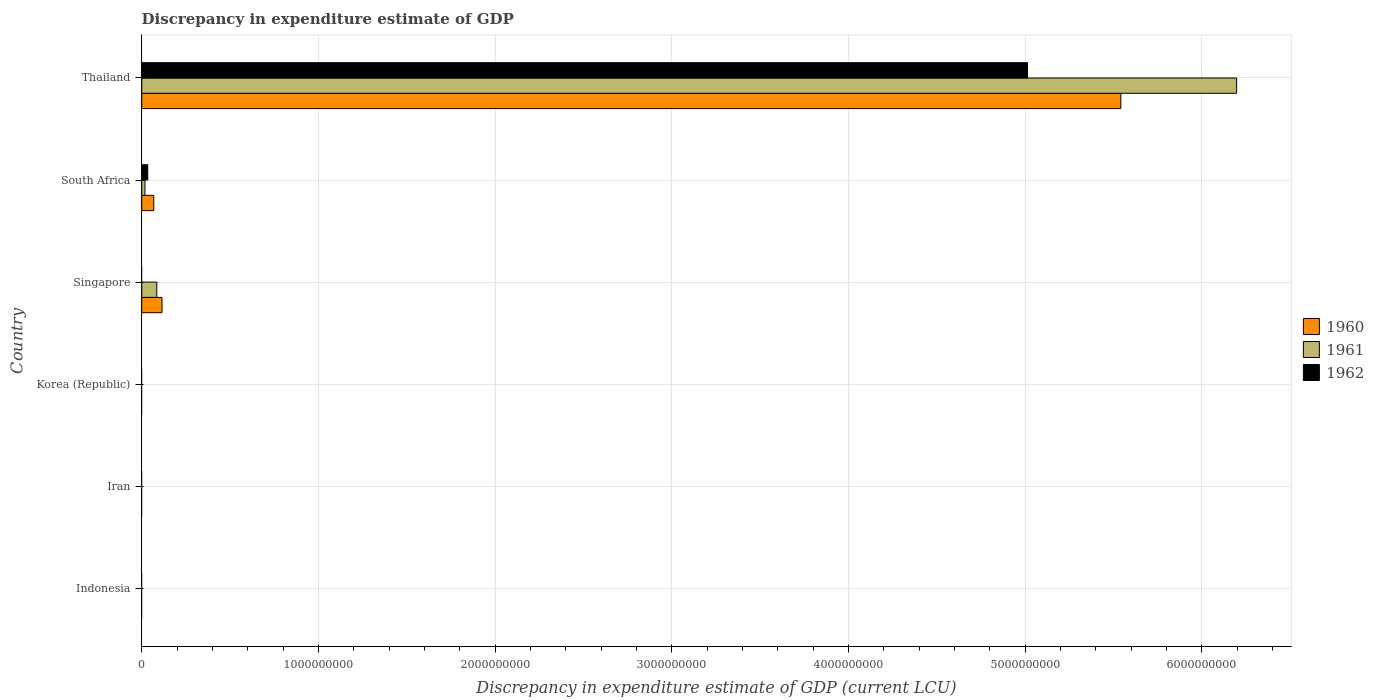How many different coloured bars are there?
Your response must be concise. 3. Are the number of bars on each tick of the Y-axis equal?
Give a very brief answer. No. How many bars are there on the 3rd tick from the bottom?
Offer a terse response. 0. What is the label of the 4th group of bars from the top?
Make the answer very short. Korea (Republic). What is the discrepancy in expenditure estimate of GDP in 1962 in Singapore?
Your answer should be compact. 0. Across all countries, what is the maximum discrepancy in expenditure estimate of GDP in 1962?
Your answer should be compact. 5.01e+09. Across all countries, what is the minimum discrepancy in expenditure estimate of GDP in 1961?
Provide a short and direct response. 0. In which country was the discrepancy in expenditure estimate of GDP in 1961 maximum?
Ensure brevity in your answer.  Thailand. What is the total discrepancy in expenditure estimate of GDP in 1962 in the graph?
Your answer should be very brief. 5.05e+09. What is the difference between the discrepancy in expenditure estimate of GDP in 1961 in Singapore and that in Thailand?
Offer a very short reply. -6.11e+09. What is the difference between the discrepancy in expenditure estimate of GDP in 1961 in South Africa and the discrepancy in expenditure estimate of GDP in 1962 in Korea (Republic)?
Provide a short and direct response. 1.84e+07. What is the average discrepancy in expenditure estimate of GDP in 1962 per country?
Ensure brevity in your answer.  8.41e+08. What is the difference between the discrepancy in expenditure estimate of GDP in 1960 and discrepancy in expenditure estimate of GDP in 1962 in Thailand?
Give a very brief answer. 5.28e+08. What is the ratio of the discrepancy in expenditure estimate of GDP in 1961 in Singapore to that in South Africa?
Your answer should be very brief. 4.64. What is the difference between the highest and the second highest discrepancy in expenditure estimate of GDP in 1960?
Keep it short and to the point. 5.43e+09. What is the difference between the highest and the lowest discrepancy in expenditure estimate of GDP in 1960?
Offer a terse response. 5.54e+09. How many bars are there?
Ensure brevity in your answer.  8. How many countries are there in the graph?
Offer a very short reply. 6. Where does the legend appear in the graph?
Your answer should be very brief. Center right. How many legend labels are there?
Keep it short and to the point. 3. How are the legend labels stacked?
Offer a very short reply. Vertical. What is the title of the graph?
Offer a very short reply. Discrepancy in expenditure estimate of GDP. What is the label or title of the X-axis?
Offer a terse response. Discrepancy in expenditure estimate of GDP (current LCU). What is the Discrepancy in expenditure estimate of GDP (current LCU) of 1961 in Indonesia?
Keep it short and to the point. 0. What is the Discrepancy in expenditure estimate of GDP (current LCU) of 1960 in Korea (Republic)?
Provide a short and direct response. 0. What is the Discrepancy in expenditure estimate of GDP (current LCU) in 1962 in Korea (Republic)?
Offer a very short reply. 0. What is the Discrepancy in expenditure estimate of GDP (current LCU) of 1960 in Singapore?
Your answer should be very brief. 1.15e+08. What is the Discrepancy in expenditure estimate of GDP (current LCU) of 1961 in Singapore?
Your response must be concise. 8.53e+07. What is the Discrepancy in expenditure estimate of GDP (current LCU) in 1962 in Singapore?
Provide a succinct answer. 0. What is the Discrepancy in expenditure estimate of GDP (current LCU) of 1960 in South Africa?
Ensure brevity in your answer.  6.83e+07. What is the Discrepancy in expenditure estimate of GDP (current LCU) of 1961 in South Africa?
Your response must be concise. 1.84e+07. What is the Discrepancy in expenditure estimate of GDP (current LCU) of 1962 in South Africa?
Provide a short and direct response. 3.40e+07. What is the Discrepancy in expenditure estimate of GDP (current LCU) in 1960 in Thailand?
Keep it short and to the point. 5.54e+09. What is the Discrepancy in expenditure estimate of GDP (current LCU) in 1961 in Thailand?
Your response must be concise. 6.20e+09. What is the Discrepancy in expenditure estimate of GDP (current LCU) in 1962 in Thailand?
Give a very brief answer. 5.01e+09. Across all countries, what is the maximum Discrepancy in expenditure estimate of GDP (current LCU) of 1960?
Provide a short and direct response. 5.54e+09. Across all countries, what is the maximum Discrepancy in expenditure estimate of GDP (current LCU) of 1961?
Provide a short and direct response. 6.20e+09. Across all countries, what is the maximum Discrepancy in expenditure estimate of GDP (current LCU) of 1962?
Provide a short and direct response. 5.01e+09. Across all countries, what is the minimum Discrepancy in expenditure estimate of GDP (current LCU) of 1961?
Provide a succinct answer. 0. What is the total Discrepancy in expenditure estimate of GDP (current LCU) in 1960 in the graph?
Your answer should be very brief. 5.72e+09. What is the total Discrepancy in expenditure estimate of GDP (current LCU) of 1961 in the graph?
Ensure brevity in your answer.  6.30e+09. What is the total Discrepancy in expenditure estimate of GDP (current LCU) in 1962 in the graph?
Offer a terse response. 5.05e+09. What is the difference between the Discrepancy in expenditure estimate of GDP (current LCU) in 1960 in Singapore and that in South Africa?
Keep it short and to the point. 4.66e+07. What is the difference between the Discrepancy in expenditure estimate of GDP (current LCU) of 1961 in Singapore and that in South Africa?
Provide a succinct answer. 6.69e+07. What is the difference between the Discrepancy in expenditure estimate of GDP (current LCU) in 1960 in Singapore and that in Thailand?
Provide a short and direct response. -5.43e+09. What is the difference between the Discrepancy in expenditure estimate of GDP (current LCU) in 1961 in Singapore and that in Thailand?
Give a very brief answer. -6.11e+09. What is the difference between the Discrepancy in expenditure estimate of GDP (current LCU) of 1960 in South Africa and that in Thailand?
Provide a succinct answer. -5.47e+09. What is the difference between the Discrepancy in expenditure estimate of GDP (current LCU) of 1961 in South Africa and that in Thailand?
Provide a short and direct response. -6.18e+09. What is the difference between the Discrepancy in expenditure estimate of GDP (current LCU) of 1962 in South Africa and that in Thailand?
Your answer should be very brief. -4.98e+09. What is the difference between the Discrepancy in expenditure estimate of GDP (current LCU) of 1960 in Singapore and the Discrepancy in expenditure estimate of GDP (current LCU) of 1961 in South Africa?
Your answer should be very brief. 9.65e+07. What is the difference between the Discrepancy in expenditure estimate of GDP (current LCU) in 1960 in Singapore and the Discrepancy in expenditure estimate of GDP (current LCU) in 1962 in South Africa?
Provide a short and direct response. 8.09e+07. What is the difference between the Discrepancy in expenditure estimate of GDP (current LCU) of 1961 in Singapore and the Discrepancy in expenditure estimate of GDP (current LCU) of 1962 in South Africa?
Make the answer very short. 5.13e+07. What is the difference between the Discrepancy in expenditure estimate of GDP (current LCU) in 1960 in Singapore and the Discrepancy in expenditure estimate of GDP (current LCU) in 1961 in Thailand?
Offer a very short reply. -6.08e+09. What is the difference between the Discrepancy in expenditure estimate of GDP (current LCU) in 1960 in Singapore and the Discrepancy in expenditure estimate of GDP (current LCU) in 1962 in Thailand?
Provide a succinct answer. -4.90e+09. What is the difference between the Discrepancy in expenditure estimate of GDP (current LCU) in 1961 in Singapore and the Discrepancy in expenditure estimate of GDP (current LCU) in 1962 in Thailand?
Offer a terse response. -4.93e+09. What is the difference between the Discrepancy in expenditure estimate of GDP (current LCU) in 1960 in South Africa and the Discrepancy in expenditure estimate of GDP (current LCU) in 1961 in Thailand?
Your answer should be compact. -6.13e+09. What is the difference between the Discrepancy in expenditure estimate of GDP (current LCU) in 1960 in South Africa and the Discrepancy in expenditure estimate of GDP (current LCU) in 1962 in Thailand?
Your response must be concise. -4.95e+09. What is the difference between the Discrepancy in expenditure estimate of GDP (current LCU) in 1961 in South Africa and the Discrepancy in expenditure estimate of GDP (current LCU) in 1962 in Thailand?
Offer a terse response. -5.00e+09. What is the average Discrepancy in expenditure estimate of GDP (current LCU) of 1960 per country?
Your answer should be very brief. 9.54e+08. What is the average Discrepancy in expenditure estimate of GDP (current LCU) of 1961 per country?
Ensure brevity in your answer.  1.05e+09. What is the average Discrepancy in expenditure estimate of GDP (current LCU) of 1962 per country?
Keep it short and to the point. 8.41e+08. What is the difference between the Discrepancy in expenditure estimate of GDP (current LCU) of 1960 and Discrepancy in expenditure estimate of GDP (current LCU) of 1961 in Singapore?
Keep it short and to the point. 2.96e+07. What is the difference between the Discrepancy in expenditure estimate of GDP (current LCU) of 1960 and Discrepancy in expenditure estimate of GDP (current LCU) of 1961 in South Africa?
Your answer should be compact. 4.99e+07. What is the difference between the Discrepancy in expenditure estimate of GDP (current LCU) of 1960 and Discrepancy in expenditure estimate of GDP (current LCU) of 1962 in South Africa?
Your answer should be compact. 3.43e+07. What is the difference between the Discrepancy in expenditure estimate of GDP (current LCU) of 1961 and Discrepancy in expenditure estimate of GDP (current LCU) of 1962 in South Africa?
Keep it short and to the point. -1.56e+07. What is the difference between the Discrepancy in expenditure estimate of GDP (current LCU) in 1960 and Discrepancy in expenditure estimate of GDP (current LCU) in 1961 in Thailand?
Keep it short and to the point. -6.56e+08. What is the difference between the Discrepancy in expenditure estimate of GDP (current LCU) of 1960 and Discrepancy in expenditure estimate of GDP (current LCU) of 1962 in Thailand?
Ensure brevity in your answer.  5.28e+08. What is the difference between the Discrepancy in expenditure estimate of GDP (current LCU) of 1961 and Discrepancy in expenditure estimate of GDP (current LCU) of 1962 in Thailand?
Give a very brief answer. 1.18e+09. What is the ratio of the Discrepancy in expenditure estimate of GDP (current LCU) in 1960 in Singapore to that in South Africa?
Give a very brief answer. 1.68. What is the ratio of the Discrepancy in expenditure estimate of GDP (current LCU) in 1961 in Singapore to that in South Africa?
Your answer should be very brief. 4.64. What is the ratio of the Discrepancy in expenditure estimate of GDP (current LCU) of 1960 in Singapore to that in Thailand?
Offer a terse response. 0.02. What is the ratio of the Discrepancy in expenditure estimate of GDP (current LCU) of 1961 in Singapore to that in Thailand?
Provide a succinct answer. 0.01. What is the ratio of the Discrepancy in expenditure estimate of GDP (current LCU) of 1960 in South Africa to that in Thailand?
Keep it short and to the point. 0.01. What is the ratio of the Discrepancy in expenditure estimate of GDP (current LCU) of 1961 in South Africa to that in Thailand?
Provide a short and direct response. 0. What is the ratio of the Discrepancy in expenditure estimate of GDP (current LCU) of 1962 in South Africa to that in Thailand?
Offer a terse response. 0.01. What is the difference between the highest and the second highest Discrepancy in expenditure estimate of GDP (current LCU) in 1960?
Offer a terse response. 5.43e+09. What is the difference between the highest and the second highest Discrepancy in expenditure estimate of GDP (current LCU) in 1961?
Ensure brevity in your answer.  6.11e+09. What is the difference between the highest and the lowest Discrepancy in expenditure estimate of GDP (current LCU) of 1960?
Your answer should be very brief. 5.54e+09. What is the difference between the highest and the lowest Discrepancy in expenditure estimate of GDP (current LCU) of 1961?
Your answer should be compact. 6.20e+09. What is the difference between the highest and the lowest Discrepancy in expenditure estimate of GDP (current LCU) of 1962?
Provide a succinct answer. 5.01e+09. 